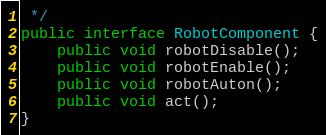Convert code to text. <code><loc_0><loc_0><loc_500><loc_500><_Java_> */
public interface RobotComponent {
    public void robotDisable();
    public void robotEnable();
    public void robotAuton();
    public void act();
}
</code> 